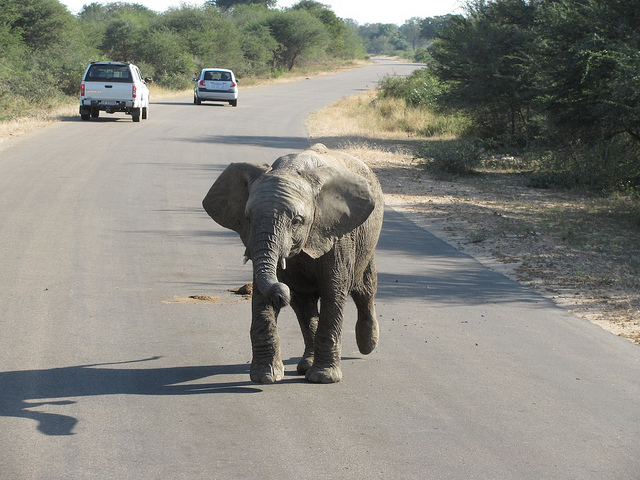Describe the environment around the elephant. The elephant is surrounded by a dry, savannah-like environment with sparse trees and shrubs, typical of a semi-arid region likely located in Africa. Could the presence of the elephant on the road pose any risks? Yes, there are risks for both the elephant and the drivers. The elephant could be hit by a vehicle, leading to injury or death, and vehicles could also get damaged or cause an accident trying to avoid the elephant. 